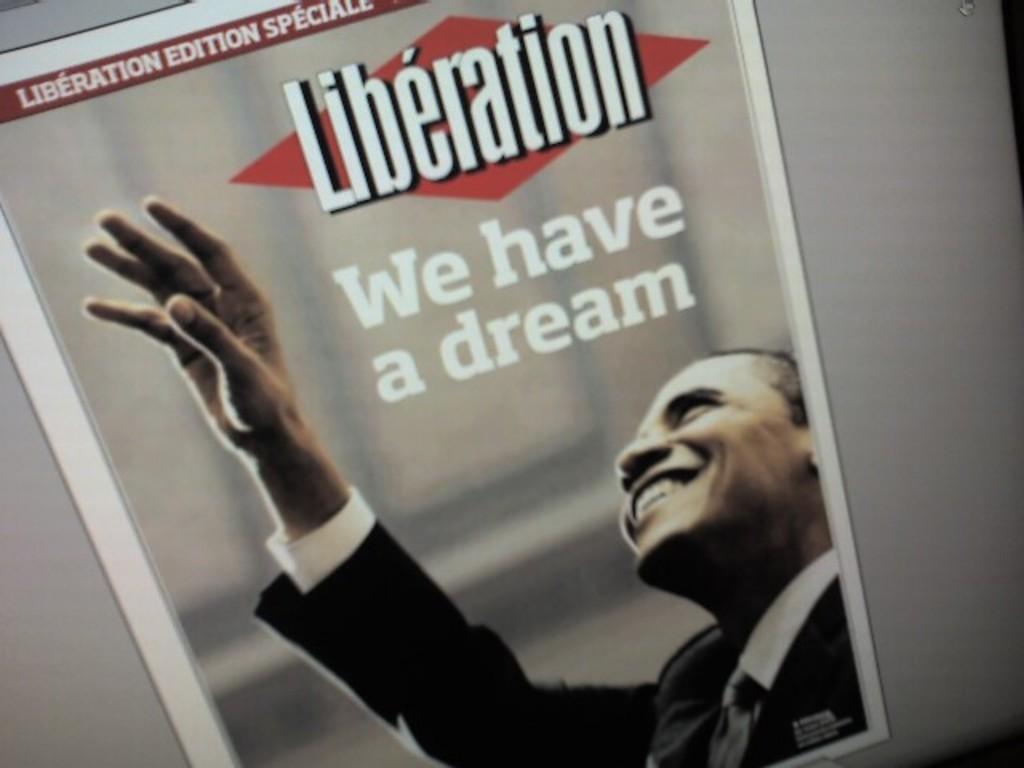How would you summarize this image in a sentence or two? In the foreground of this image, it seems like a screen and on the screen there is a poster. 